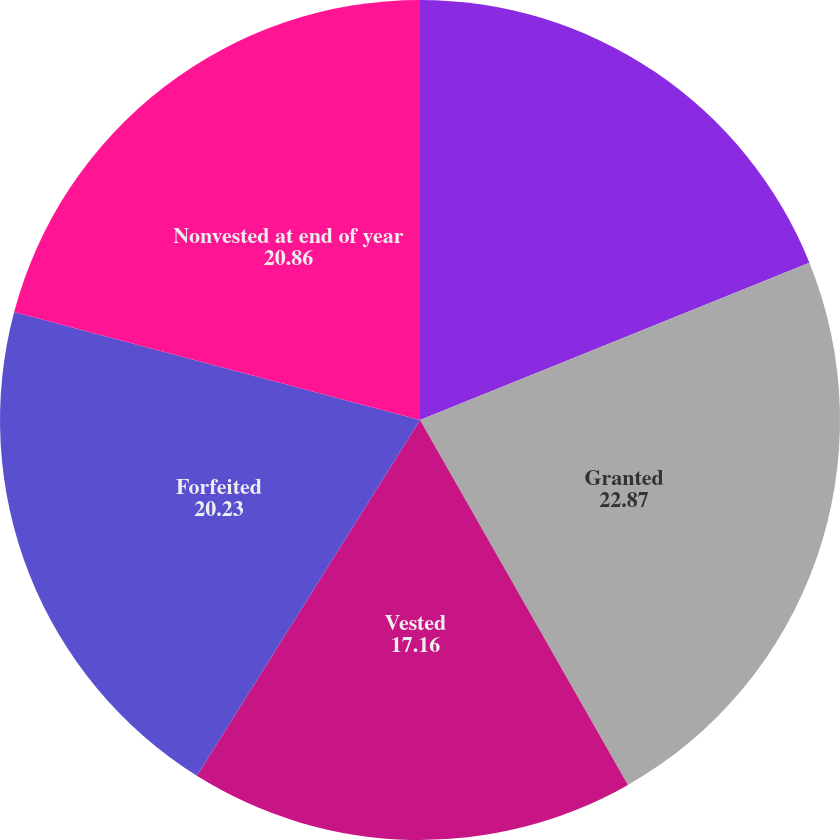Convert chart to OTSL. <chart><loc_0><loc_0><loc_500><loc_500><pie_chart><fcel>Nonvested at beginning of year<fcel>Granted<fcel>Vested<fcel>Forfeited<fcel>Nonvested at end of year<nl><fcel>18.89%<fcel>22.87%<fcel>17.16%<fcel>20.23%<fcel>20.86%<nl></chart> 